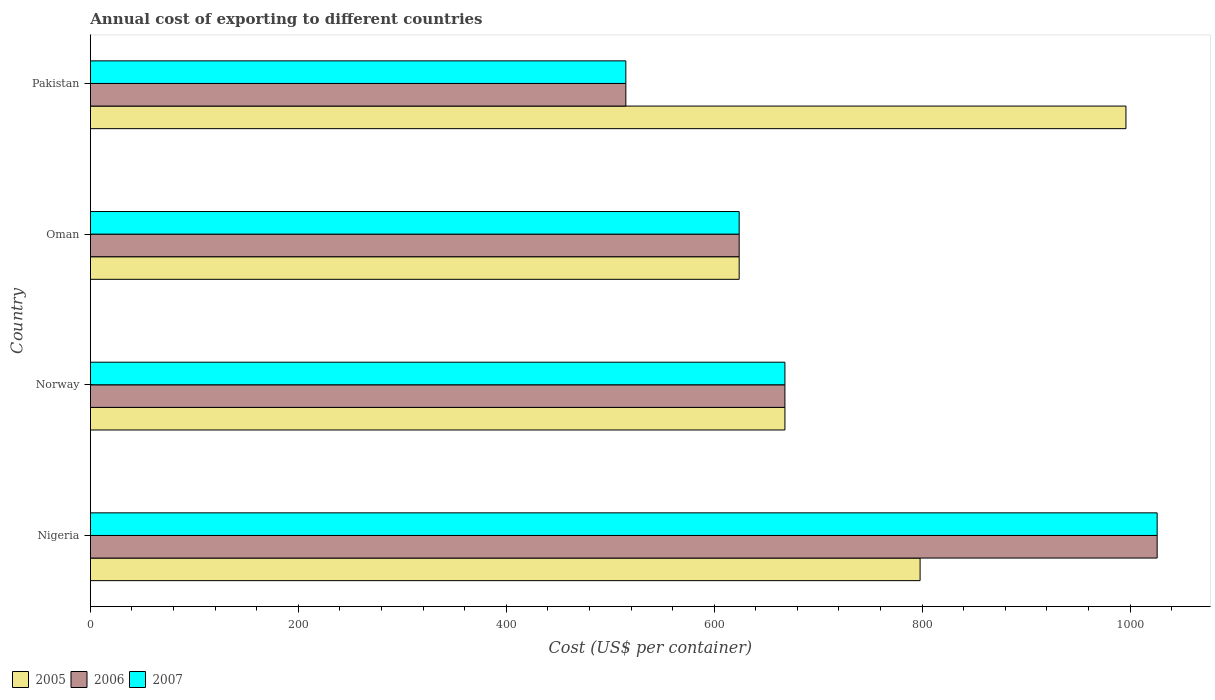How many groups of bars are there?
Offer a terse response. 4. Are the number of bars per tick equal to the number of legend labels?
Provide a short and direct response. Yes. Are the number of bars on each tick of the Y-axis equal?
Your response must be concise. Yes. How many bars are there on the 1st tick from the top?
Your answer should be compact. 3. How many bars are there on the 3rd tick from the bottom?
Give a very brief answer. 3. What is the label of the 1st group of bars from the top?
Your answer should be very brief. Pakistan. In how many cases, is the number of bars for a given country not equal to the number of legend labels?
Provide a short and direct response. 0. What is the total annual cost of exporting in 2007 in Norway?
Provide a succinct answer. 668. Across all countries, what is the maximum total annual cost of exporting in 2007?
Provide a short and direct response. 1026. Across all countries, what is the minimum total annual cost of exporting in 2005?
Your answer should be compact. 624. What is the total total annual cost of exporting in 2005 in the graph?
Make the answer very short. 3086. What is the difference between the total annual cost of exporting in 2005 in Nigeria and that in Oman?
Offer a very short reply. 174. What is the difference between the total annual cost of exporting in 2007 in Pakistan and the total annual cost of exporting in 2006 in Nigeria?
Offer a terse response. -511. What is the average total annual cost of exporting in 2005 per country?
Ensure brevity in your answer.  771.5. What is the difference between the total annual cost of exporting in 2005 and total annual cost of exporting in 2007 in Nigeria?
Your answer should be compact. -228. What is the ratio of the total annual cost of exporting in 2006 in Nigeria to that in Norway?
Ensure brevity in your answer.  1.54. Is the total annual cost of exporting in 2006 in Nigeria less than that in Oman?
Provide a succinct answer. No. Is the difference between the total annual cost of exporting in 2005 in Oman and Pakistan greater than the difference between the total annual cost of exporting in 2007 in Oman and Pakistan?
Your answer should be very brief. No. What is the difference between the highest and the second highest total annual cost of exporting in 2005?
Offer a terse response. 198. What is the difference between the highest and the lowest total annual cost of exporting in 2005?
Offer a terse response. 372. Is the sum of the total annual cost of exporting in 2005 in Oman and Pakistan greater than the maximum total annual cost of exporting in 2006 across all countries?
Your response must be concise. Yes. What does the 3rd bar from the top in Nigeria represents?
Offer a terse response. 2005. How many bars are there?
Make the answer very short. 12. Are all the bars in the graph horizontal?
Your response must be concise. Yes. How many countries are there in the graph?
Keep it short and to the point. 4. Are the values on the major ticks of X-axis written in scientific E-notation?
Ensure brevity in your answer.  No. Does the graph contain grids?
Your answer should be compact. No. How many legend labels are there?
Your response must be concise. 3. How are the legend labels stacked?
Ensure brevity in your answer.  Horizontal. What is the title of the graph?
Offer a terse response. Annual cost of exporting to different countries. Does "1969" appear as one of the legend labels in the graph?
Your response must be concise. No. What is the label or title of the X-axis?
Keep it short and to the point. Cost (US$ per container). What is the label or title of the Y-axis?
Keep it short and to the point. Country. What is the Cost (US$ per container) in 2005 in Nigeria?
Your response must be concise. 798. What is the Cost (US$ per container) of 2006 in Nigeria?
Your answer should be compact. 1026. What is the Cost (US$ per container) in 2007 in Nigeria?
Keep it short and to the point. 1026. What is the Cost (US$ per container) in 2005 in Norway?
Offer a very short reply. 668. What is the Cost (US$ per container) in 2006 in Norway?
Keep it short and to the point. 668. What is the Cost (US$ per container) of 2007 in Norway?
Your answer should be compact. 668. What is the Cost (US$ per container) of 2005 in Oman?
Give a very brief answer. 624. What is the Cost (US$ per container) of 2006 in Oman?
Your answer should be compact. 624. What is the Cost (US$ per container) of 2007 in Oman?
Your answer should be very brief. 624. What is the Cost (US$ per container) in 2005 in Pakistan?
Your response must be concise. 996. What is the Cost (US$ per container) in 2006 in Pakistan?
Your answer should be very brief. 515. What is the Cost (US$ per container) of 2007 in Pakistan?
Give a very brief answer. 515. Across all countries, what is the maximum Cost (US$ per container) in 2005?
Your answer should be compact. 996. Across all countries, what is the maximum Cost (US$ per container) in 2006?
Your response must be concise. 1026. Across all countries, what is the maximum Cost (US$ per container) of 2007?
Provide a succinct answer. 1026. Across all countries, what is the minimum Cost (US$ per container) of 2005?
Your response must be concise. 624. Across all countries, what is the minimum Cost (US$ per container) of 2006?
Make the answer very short. 515. Across all countries, what is the minimum Cost (US$ per container) of 2007?
Your answer should be compact. 515. What is the total Cost (US$ per container) of 2005 in the graph?
Your answer should be very brief. 3086. What is the total Cost (US$ per container) of 2006 in the graph?
Give a very brief answer. 2833. What is the total Cost (US$ per container) of 2007 in the graph?
Your answer should be very brief. 2833. What is the difference between the Cost (US$ per container) of 2005 in Nigeria and that in Norway?
Provide a succinct answer. 130. What is the difference between the Cost (US$ per container) of 2006 in Nigeria and that in Norway?
Your response must be concise. 358. What is the difference between the Cost (US$ per container) of 2007 in Nigeria and that in Norway?
Provide a short and direct response. 358. What is the difference between the Cost (US$ per container) of 2005 in Nigeria and that in Oman?
Provide a short and direct response. 174. What is the difference between the Cost (US$ per container) in 2006 in Nigeria and that in Oman?
Your answer should be very brief. 402. What is the difference between the Cost (US$ per container) in 2007 in Nigeria and that in Oman?
Provide a short and direct response. 402. What is the difference between the Cost (US$ per container) in 2005 in Nigeria and that in Pakistan?
Ensure brevity in your answer.  -198. What is the difference between the Cost (US$ per container) in 2006 in Nigeria and that in Pakistan?
Make the answer very short. 511. What is the difference between the Cost (US$ per container) of 2007 in Nigeria and that in Pakistan?
Offer a terse response. 511. What is the difference between the Cost (US$ per container) in 2005 in Norway and that in Oman?
Your answer should be compact. 44. What is the difference between the Cost (US$ per container) of 2006 in Norway and that in Oman?
Make the answer very short. 44. What is the difference between the Cost (US$ per container) of 2005 in Norway and that in Pakistan?
Keep it short and to the point. -328. What is the difference between the Cost (US$ per container) in 2006 in Norway and that in Pakistan?
Offer a very short reply. 153. What is the difference between the Cost (US$ per container) in 2007 in Norway and that in Pakistan?
Keep it short and to the point. 153. What is the difference between the Cost (US$ per container) of 2005 in Oman and that in Pakistan?
Your answer should be compact. -372. What is the difference between the Cost (US$ per container) of 2006 in Oman and that in Pakistan?
Offer a terse response. 109. What is the difference between the Cost (US$ per container) of 2007 in Oman and that in Pakistan?
Your answer should be compact. 109. What is the difference between the Cost (US$ per container) of 2005 in Nigeria and the Cost (US$ per container) of 2006 in Norway?
Make the answer very short. 130. What is the difference between the Cost (US$ per container) in 2005 in Nigeria and the Cost (US$ per container) in 2007 in Norway?
Ensure brevity in your answer.  130. What is the difference between the Cost (US$ per container) in 2006 in Nigeria and the Cost (US$ per container) in 2007 in Norway?
Make the answer very short. 358. What is the difference between the Cost (US$ per container) of 2005 in Nigeria and the Cost (US$ per container) of 2006 in Oman?
Your response must be concise. 174. What is the difference between the Cost (US$ per container) of 2005 in Nigeria and the Cost (US$ per container) of 2007 in Oman?
Offer a terse response. 174. What is the difference between the Cost (US$ per container) of 2006 in Nigeria and the Cost (US$ per container) of 2007 in Oman?
Give a very brief answer. 402. What is the difference between the Cost (US$ per container) in 2005 in Nigeria and the Cost (US$ per container) in 2006 in Pakistan?
Offer a very short reply. 283. What is the difference between the Cost (US$ per container) in 2005 in Nigeria and the Cost (US$ per container) in 2007 in Pakistan?
Keep it short and to the point. 283. What is the difference between the Cost (US$ per container) in 2006 in Nigeria and the Cost (US$ per container) in 2007 in Pakistan?
Keep it short and to the point. 511. What is the difference between the Cost (US$ per container) of 2005 in Norway and the Cost (US$ per container) of 2007 in Oman?
Make the answer very short. 44. What is the difference between the Cost (US$ per container) in 2005 in Norway and the Cost (US$ per container) in 2006 in Pakistan?
Offer a very short reply. 153. What is the difference between the Cost (US$ per container) of 2005 in Norway and the Cost (US$ per container) of 2007 in Pakistan?
Your answer should be compact. 153. What is the difference between the Cost (US$ per container) of 2006 in Norway and the Cost (US$ per container) of 2007 in Pakistan?
Offer a very short reply. 153. What is the difference between the Cost (US$ per container) of 2005 in Oman and the Cost (US$ per container) of 2006 in Pakistan?
Make the answer very short. 109. What is the difference between the Cost (US$ per container) in 2005 in Oman and the Cost (US$ per container) in 2007 in Pakistan?
Make the answer very short. 109. What is the difference between the Cost (US$ per container) in 2006 in Oman and the Cost (US$ per container) in 2007 in Pakistan?
Your response must be concise. 109. What is the average Cost (US$ per container) of 2005 per country?
Your response must be concise. 771.5. What is the average Cost (US$ per container) in 2006 per country?
Give a very brief answer. 708.25. What is the average Cost (US$ per container) of 2007 per country?
Ensure brevity in your answer.  708.25. What is the difference between the Cost (US$ per container) in 2005 and Cost (US$ per container) in 2006 in Nigeria?
Offer a terse response. -228. What is the difference between the Cost (US$ per container) in 2005 and Cost (US$ per container) in 2007 in Nigeria?
Your response must be concise. -228. What is the difference between the Cost (US$ per container) in 2006 and Cost (US$ per container) in 2007 in Norway?
Provide a succinct answer. 0. What is the difference between the Cost (US$ per container) in 2005 and Cost (US$ per container) in 2007 in Oman?
Your answer should be compact. 0. What is the difference between the Cost (US$ per container) of 2005 and Cost (US$ per container) of 2006 in Pakistan?
Make the answer very short. 481. What is the difference between the Cost (US$ per container) of 2005 and Cost (US$ per container) of 2007 in Pakistan?
Give a very brief answer. 481. What is the ratio of the Cost (US$ per container) of 2005 in Nigeria to that in Norway?
Make the answer very short. 1.19. What is the ratio of the Cost (US$ per container) in 2006 in Nigeria to that in Norway?
Make the answer very short. 1.54. What is the ratio of the Cost (US$ per container) in 2007 in Nigeria to that in Norway?
Offer a terse response. 1.54. What is the ratio of the Cost (US$ per container) in 2005 in Nigeria to that in Oman?
Make the answer very short. 1.28. What is the ratio of the Cost (US$ per container) in 2006 in Nigeria to that in Oman?
Your response must be concise. 1.64. What is the ratio of the Cost (US$ per container) of 2007 in Nigeria to that in Oman?
Your answer should be very brief. 1.64. What is the ratio of the Cost (US$ per container) in 2005 in Nigeria to that in Pakistan?
Your response must be concise. 0.8. What is the ratio of the Cost (US$ per container) of 2006 in Nigeria to that in Pakistan?
Your answer should be very brief. 1.99. What is the ratio of the Cost (US$ per container) of 2007 in Nigeria to that in Pakistan?
Your answer should be compact. 1.99. What is the ratio of the Cost (US$ per container) in 2005 in Norway to that in Oman?
Your response must be concise. 1.07. What is the ratio of the Cost (US$ per container) in 2006 in Norway to that in Oman?
Your answer should be compact. 1.07. What is the ratio of the Cost (US$ per container) of 2007 in Norway to that in Oman?
Your response must be concise. 1.07. What is the ratio of the Cost (US$ per container) of 2005 in Norway to that in Pakistan?
Keep it short and to the point. 0.67. What is the ratio of the Cost (US$ per container) of 2006 in Norway to that in Pakistan?
Provide a short and direct response. 1.3. What is the ratio of the Cost (US$ per container) of 2007 in Norway to that in Pakistan?
Give a very brief answer. 1.3. What is the ratio of the Cost (US$ per container) of 2005 in Oman to that in Pakistan?
Ensure brevity in your answer.  0.63. What is the ratio of the Cost (US$ per container) in 2006 in Oman to that in Pakistan?
Your answer should be very brief. 1.21. What is the ratio of the Cost (US$ per container) in 2007 in Oman to that in Pakistan?
Ensure brevity in your answer.  1.21. What is the difference between the highest and the second highest Cost (US$ per container) in 2005?
Ensure brevity in your answer.  198. What is the difference between the highest and the second highest Cost (US$ per container) of 2006?
Offer a very short reply. 358. What is the difference between the highest and the second highest Cost (US$ per container) of 2007?
Offer a very short reply. 358. What is the difference between the highest and the lowest Cost (US$ per container) of 2005?
Provide a short and direct response. 372. What is the difference between the highest and the lowest Cost (US$ per container) of 2006?
Offer a terse response. 511. What is the difference between the highest and the lowest Cost (US$ per container) of 2007?
Make the answer very short. 511. 